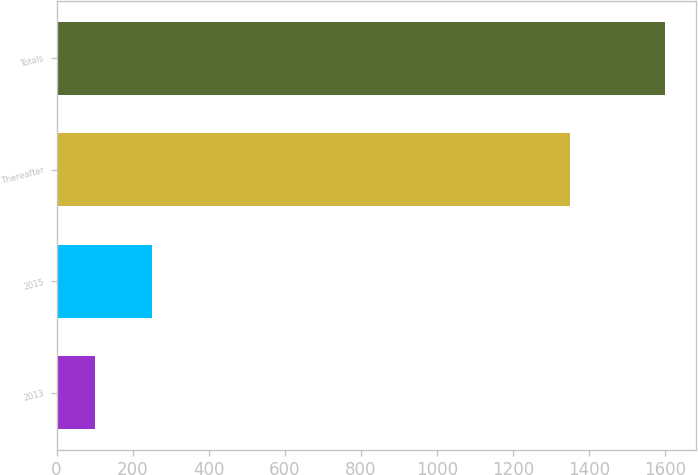<chart> <loc_0><loc_0><loc_500><loc_500><bar_chart><fcel>2013<fcel>2015<fcel>Thereafter<fcel>Totals<nl><fcel>100<fcel>250<fcel>1350<fcel>1600<nl></chart> 